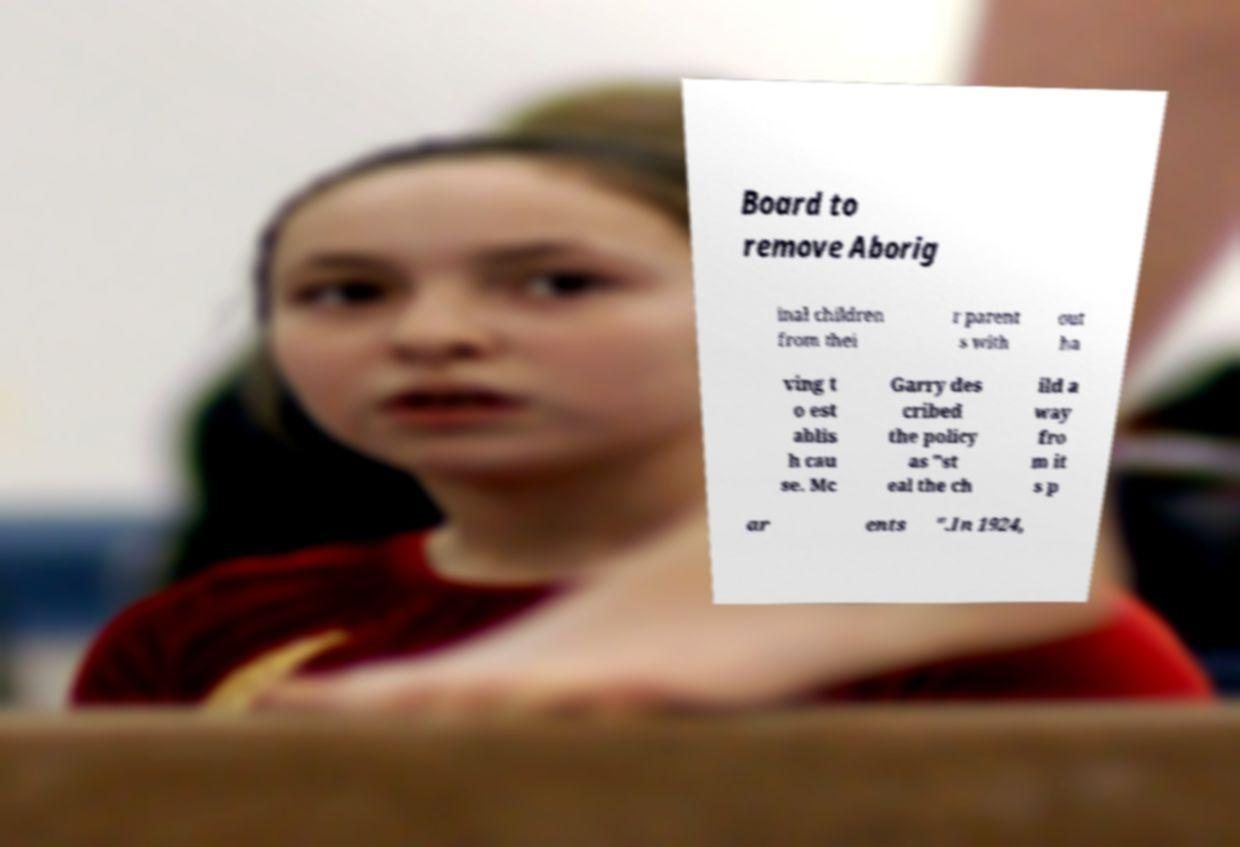Can you accurately transcribe the text from the provided image for me? Board to remove Aborig inal children from thei r parent s with out ha ving t o est ablis h cau se. Mc Garry des cribed the policy as "st eal the ch ild a way fro m it s p ar ents ".In 1924, 